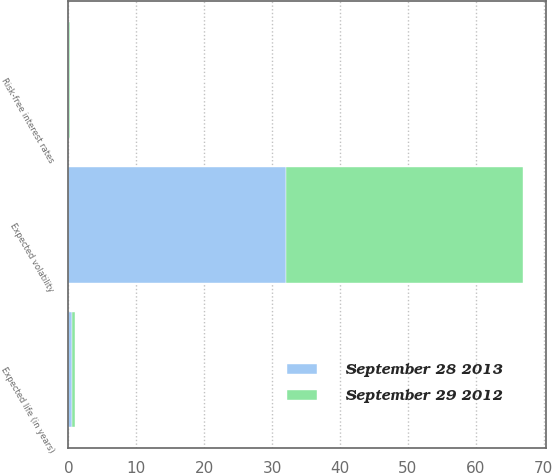Convert chart to OTSL. <chart><loc_0><loc_0><loc_500><loc_500><stacked_bar_chart><ecel><fcel>Risk-free interest rates<fcel>Expected life (in years)<fcel>Expected volatility<nl><fcel>September 28 2013<fcel>0.11<fcel>0.5<fcel>32<nl><fcel>September 29 2012<fcel>0.16<fcel>0.5<fcel>35<nl></chart> 